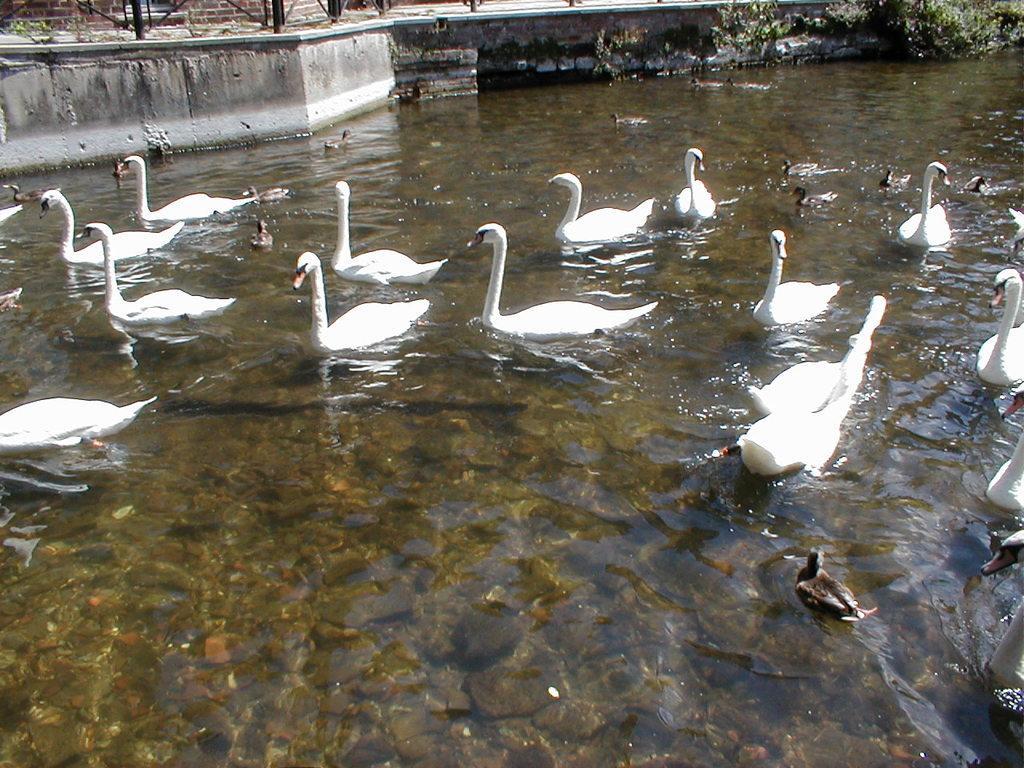In one or two sentences, can you explain what this image depicts? There are many ducks and swans in the water. Near to the water there is a wall. Also there are plants. At the top we can see a brick wall. Also there are stones in the water. 